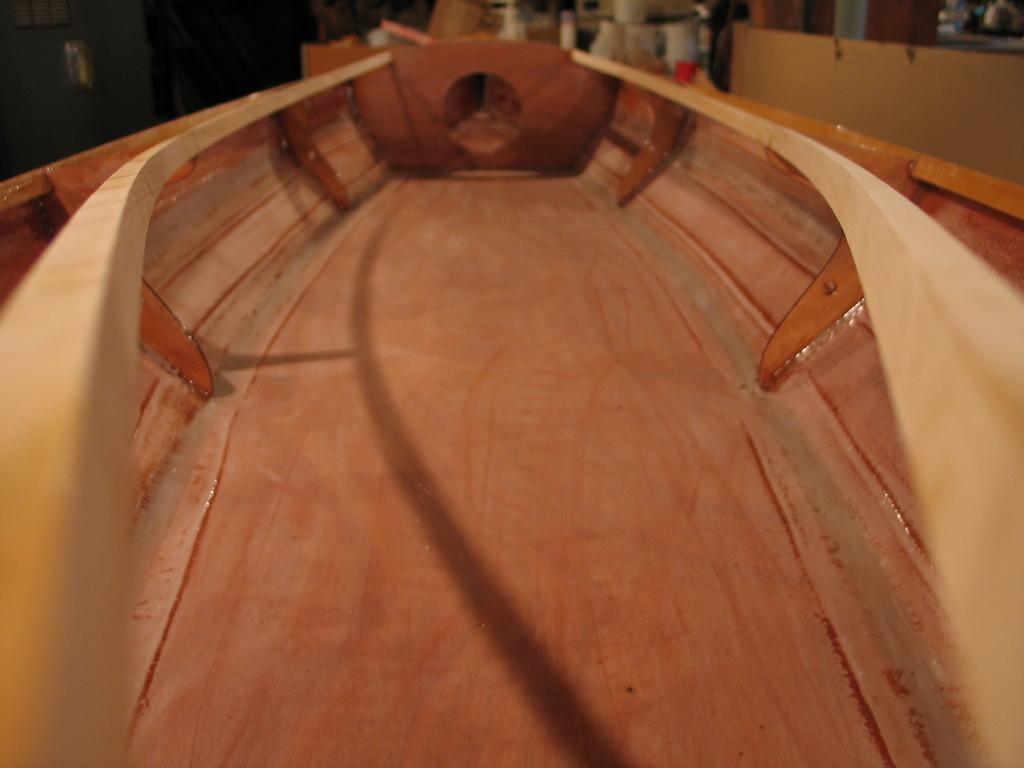Describe this image in one or two sentences. In the center of the image a boat is present. 